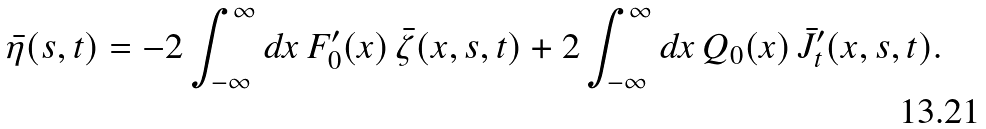Convert formula to latex. <formula><loc_0><loc_0><loc_500><loc_500>\bar { \eta } ( s , t ) = - 2 \int _ { - \infty } ^ { \infty } d x \, F _ { 0 } ^ { \prime } ( x ) \, \bar { \zeta } ( x , s , t ) + 2 \int _ { - \infty } ^ { \infty } d x \, Q _ { 0 } ( x ) \, \bar { J } _ { t } ^ { \prime } ( x , s , t ) .</formula> 